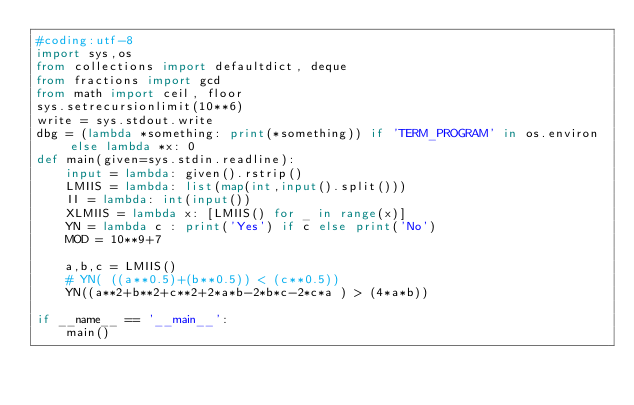Convert code to text. <code><loc_0><loc_0><loc_500><loc_500><_Python_>#coding:utf-8
import sys,os
from collections import defaultdict, deque
from fractions import gcd
from math import ceil, floor
sys.setrecursionlimit(10**6)
write = sys.stdout.write
dbg = (lambda *something: print(*something)) if 'TERM_PROGRAM' in os.environ else lambda *x: 0
def main(given=sys.stdin.readline):
    input = lambda: given().rstrip()
    LMIIS = lambda: list(map(int,input().split()))
    II = lambda: int(input())
    XLMIIS = lambda x: [LMIIS() for _ in range(x)]
    YN = lambda c : print('Yes') if c else print('No')
    MOD = 10**9+7

    a,b,c = LMIIS()
    # YN( ((a**0.5)+(b**0.5)) < (c**0.5))
    YN((a**2+b**2+c**2+2*a*b-2*b*c-2*c*a ) > (4*a*b))

if __name__ == '__main__':
    main()</code> 